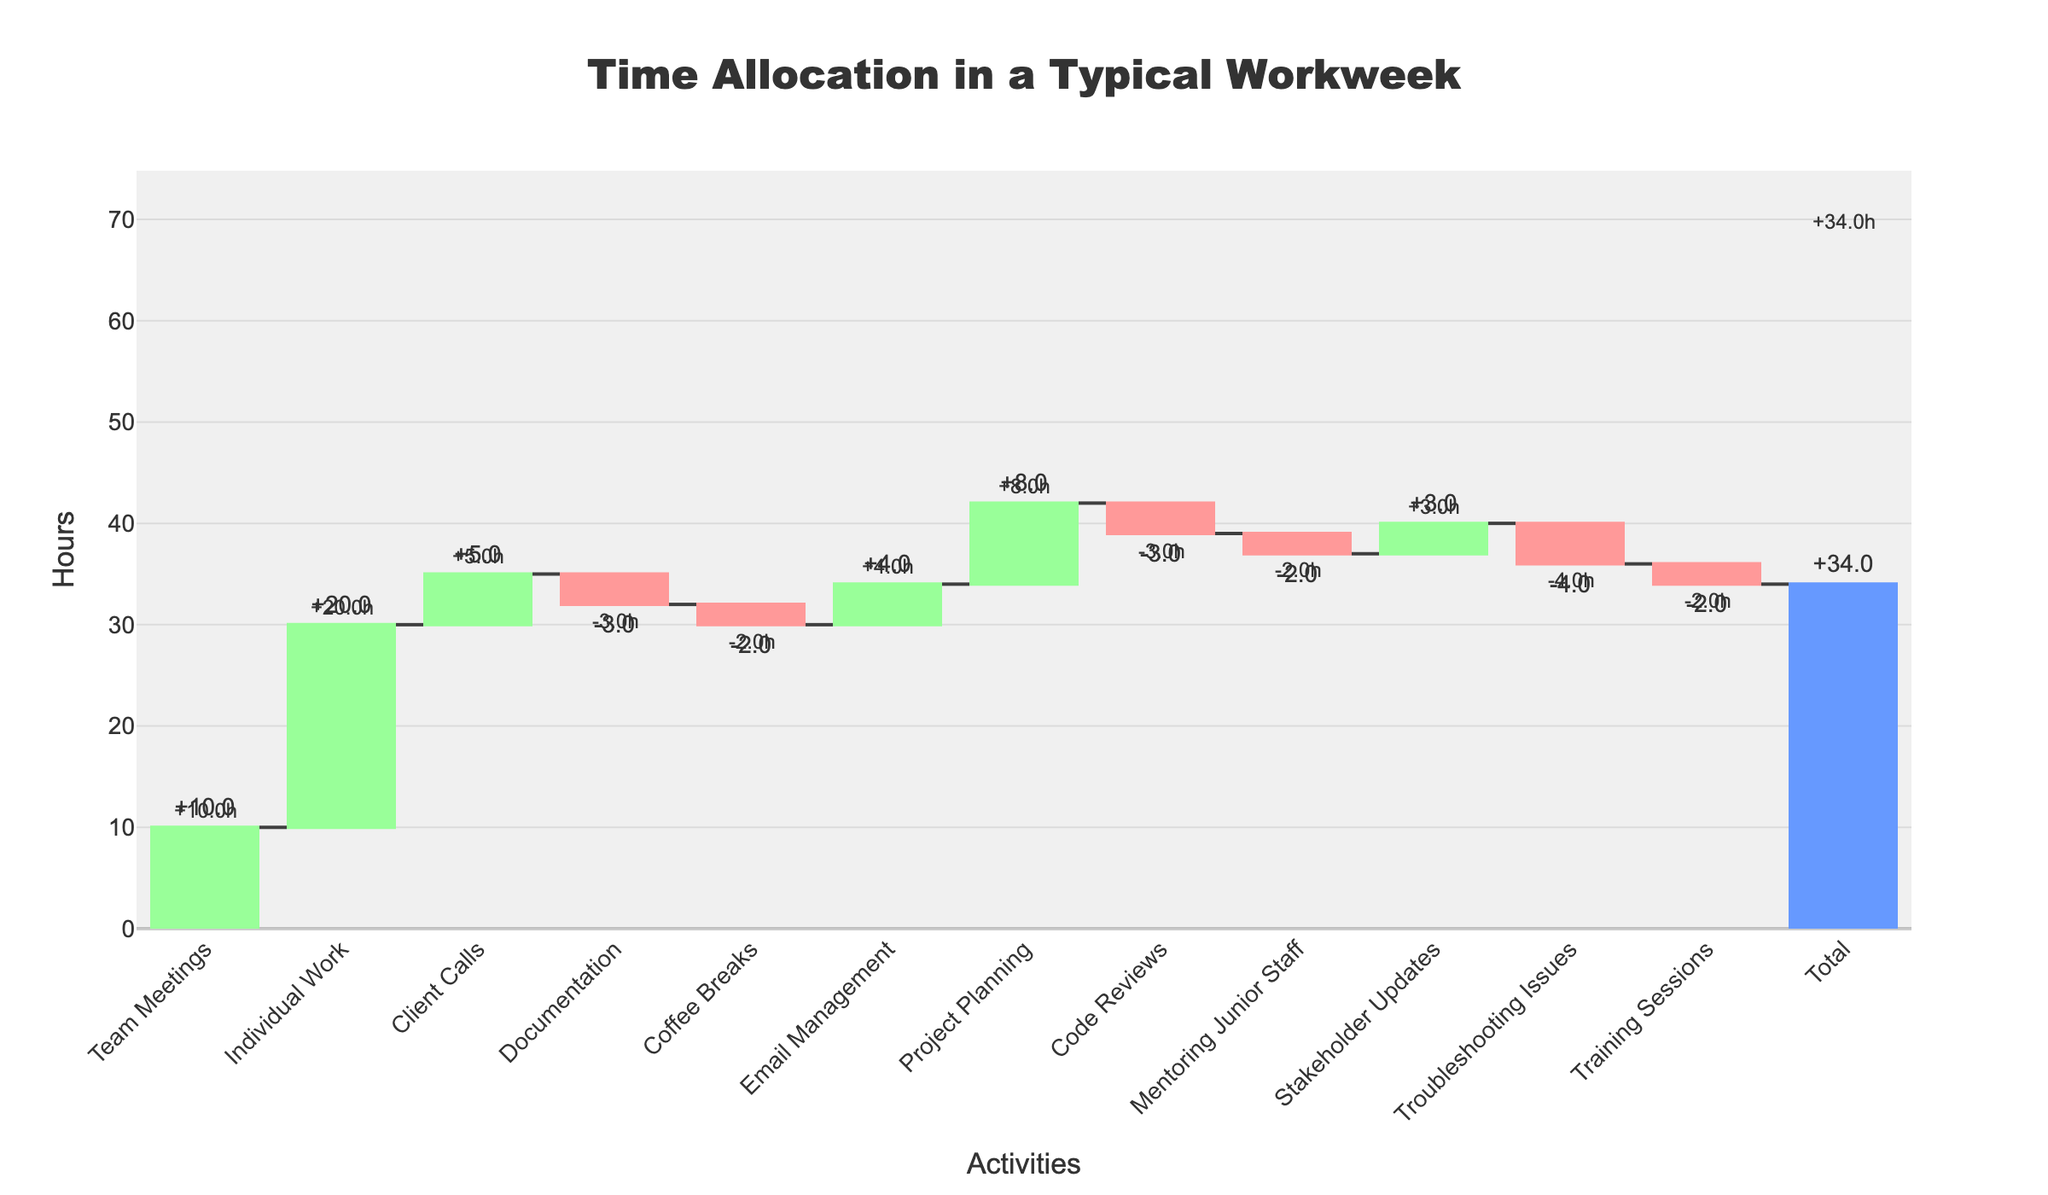What is the title of the chart? The title of a chart is usually displayed at the top, providing a summary about the chart's purpose or the data it represents. Here, the title is clearly readable at the top center of the chart.
Answer: "Time Allocation in a Typical Workweek" How many hours are spent on Coffee Breaks? To determine the hours spent on Coffee Breaks, we look at the bar labeled "Coffee Breaks." The text outside the corresponding bar shows the value.
Answer: -2 hours Which activity has the highest positive time allocation? The activity with the highest positive time allocation will have the tallest increasing bar. In this case, "Individual Work" has the tallest green bar.
Answer: Individual Work How does the time spent on Documentation compare to that on Code Reviews? To compare these two activities, look at the "Documentation" and "Code Reviews" bars. Both are decreasing bars, and their values can be read directly from the text outside the bars.
Answer: Both have -3 hours What is the total time spent on activities during the workweek? The total time is usually indicated by a distinctive bar (blue in this case) and can be read from the label outside of it.
Answer: 34 hours What is the net effect of non-work-related activities (Coffee Breaks and Email Management)? Add the hours for Coffee Breaks and Email Management to find the net effect on productivity by these non-work-related activities. Coffee Breaks: -2 hours, Email Management: +4 hours.
Answer: +2 hours Which activity contributes the least amount of time? To find this, we look for the smallest bar in the waterfall chart. The smallest absolute bar (negative) is "Troubleshooting Issues."
Answer: Troubleshooting Issues (-4 hours) How much more time is spent on Team Meetings compared to Client Calls? Subtract the time spent on Client Calls from the time spent on Team Meetings. Team Meetings: 10 hours, Client Calls: 5 hours.
Answer: 5 hours more What is the cumulative effect of Individual Work, Client Calls, and Documentation combined? Sum the hours associated with Individual Work, Client Calls, and Documentation. Individual Work: 20 hours, Client Calls: 5 hours, Documentation: -3 hours. (20 + 5 - 3 = 22)
Answer: 22 hours How do Client Calls affect the cumulative work-time allocation? Client Calls is an increasing activity, indicated by a green bar. Its value adds positively to the cumulative work-time.
Answer: It adds 5 hours 